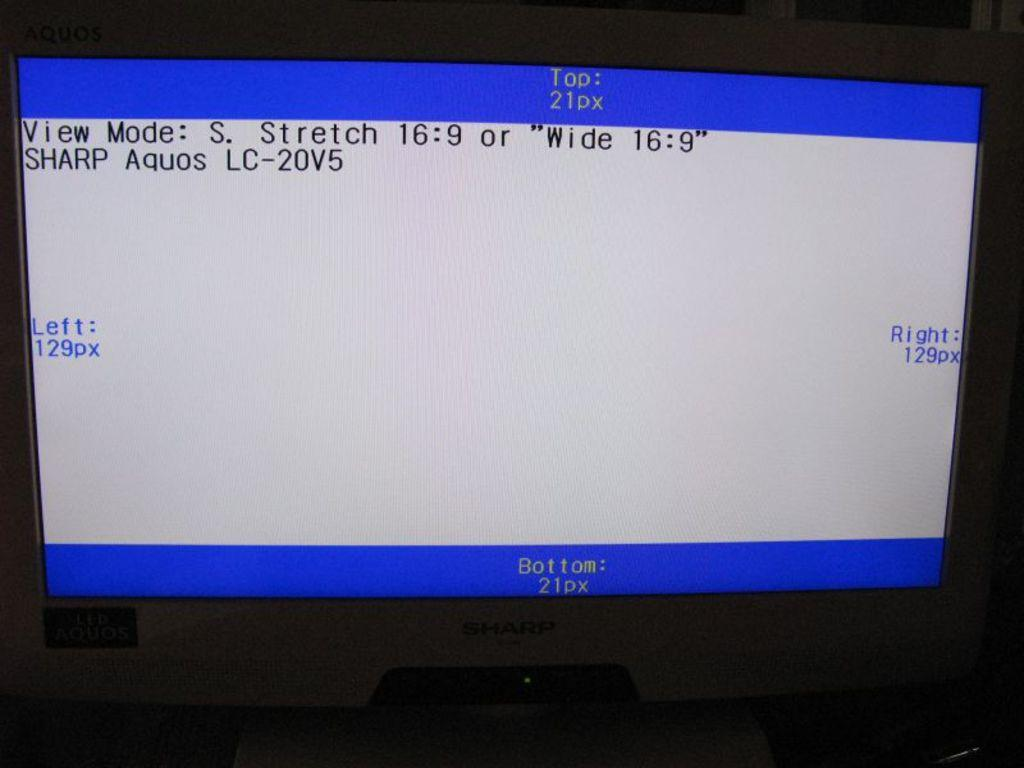<image>
Give a short and clear explanation of the subsequent image. A computer display shows its View Mode settings. 